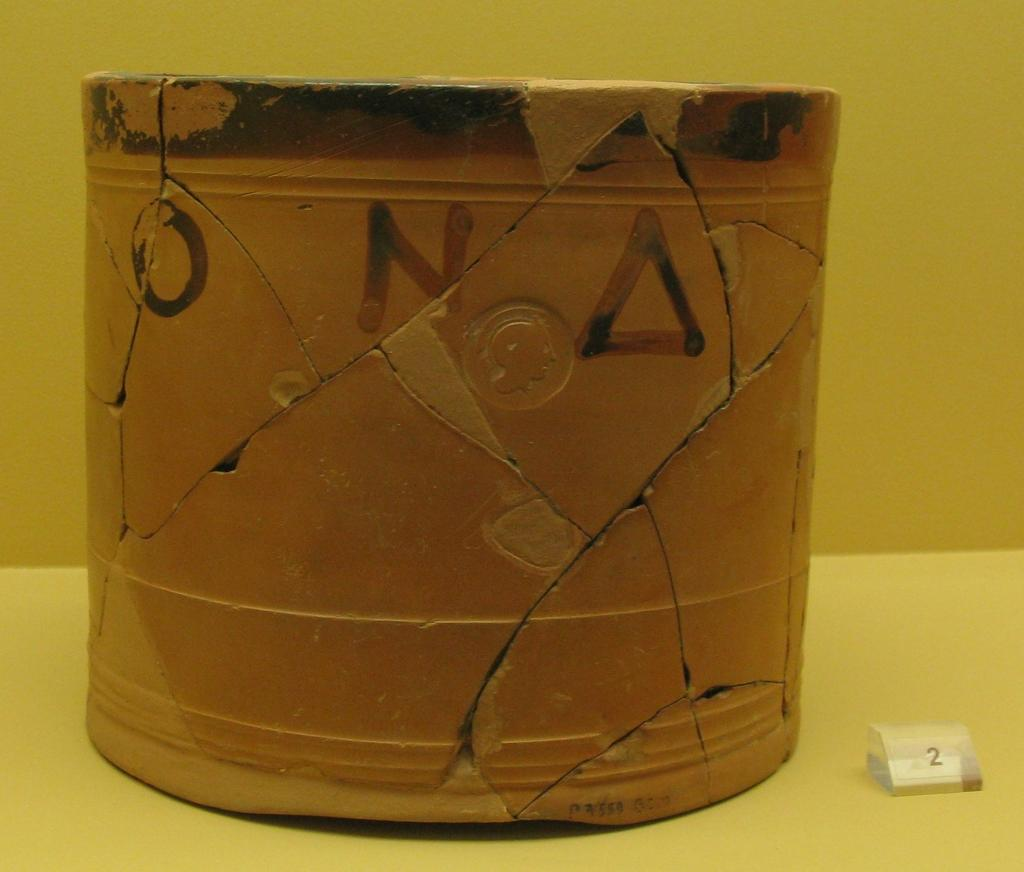<image>
Give a short and clear explanation of the subsequent image. The cracked vase has the letter N on it 